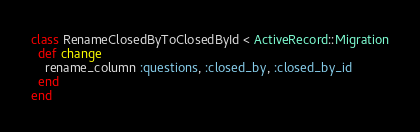Convert code to text. <code><loc_0><loc_0><loc_500><loc_500><_Ruby_>class RenameClosedByToClosedById < ActiveRecord::Migration
  def change
    rename_column :questions, :closed_by, :closed_by_id
  end
end
</code> 